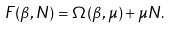Convert formula to latex. <formula><loc_0><loc_0><loc_500><loc_500>F ( \beta , N ) = \Omega ( \beta , \mu ) + \mu N .</formula> 